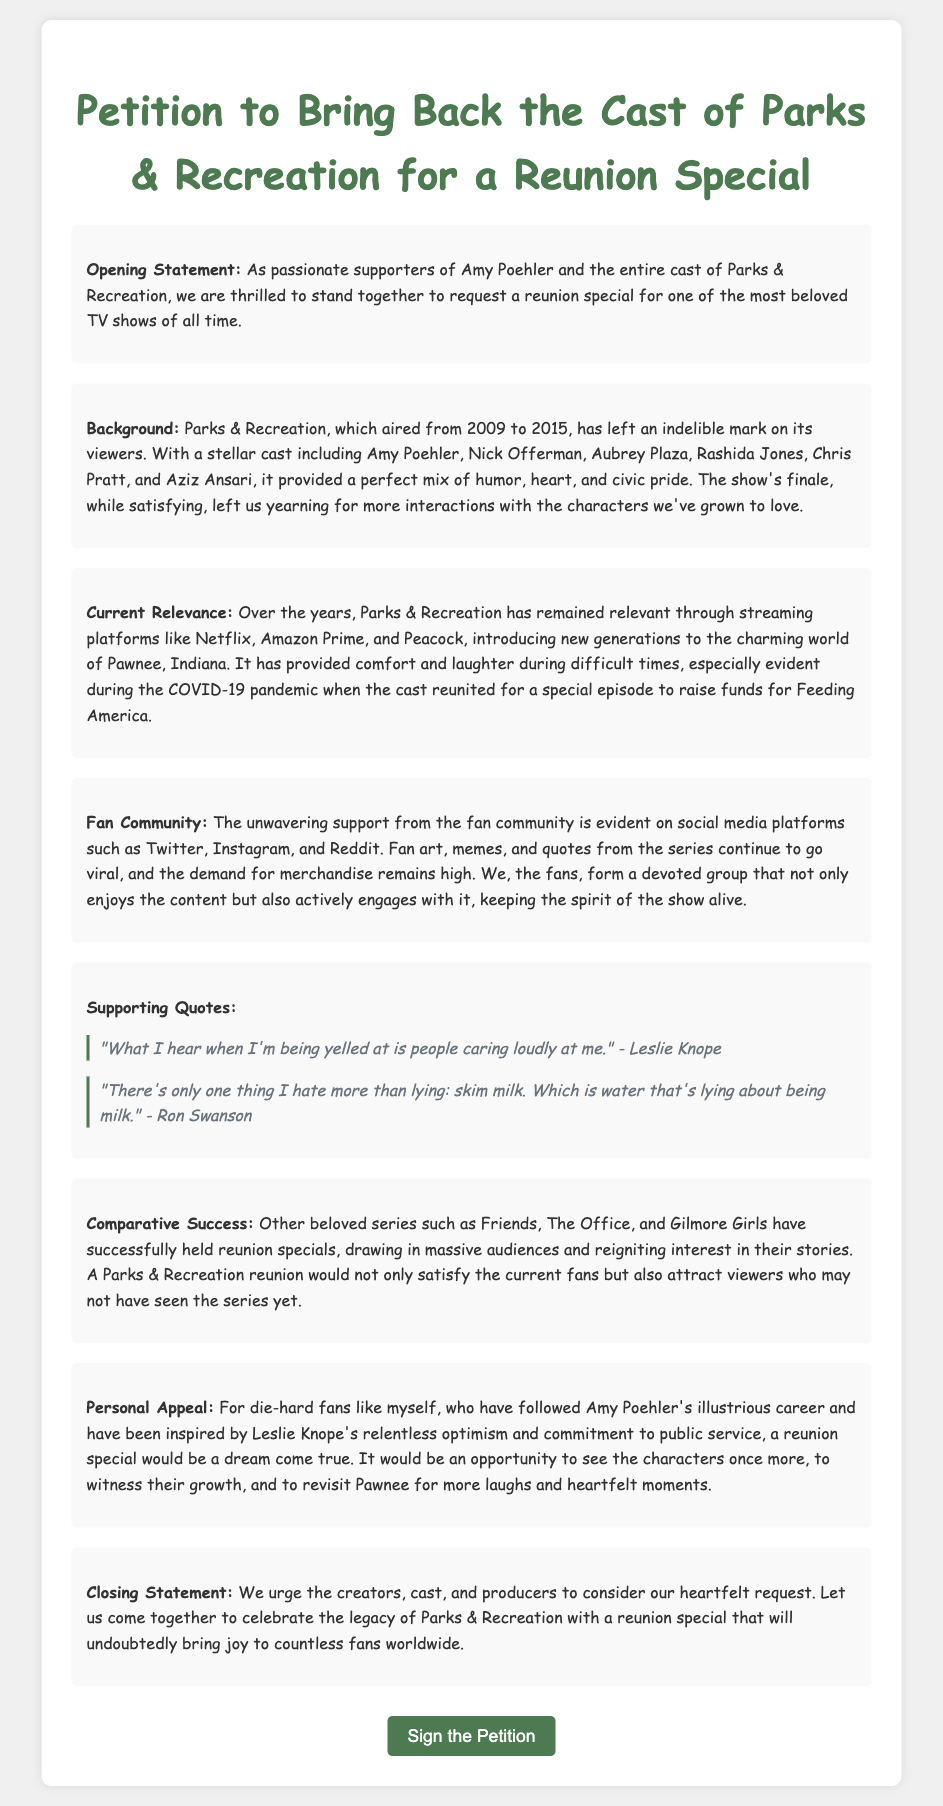What is the title of the petition? The title of the petition is explicitly stated at the top of the document.
Answer: Petition to Bring Back the Cast of Parks & Recreation for a Reunion Special Who is the creator of the character Leslie Knope? Leslie Knope is played by Amy Poehler, a main cast member and a driving force behind the show.
Answer: Amy Poehler What year did Parks & Recreation first air? The document mentions the airing period of the show clearly.
Answer: 2009 What was the purpose of the special episode during the COVID-19 pandemic? The document refers to an event that aimed to aid a charitable cause.
Answer: To raise funds for Feeding America Which platforms have kept Parks & Recreation relevant? The document lists the streaming platforms that have introduced the show to new audiences.
Answer: Netflix, Amazon Prime, and Peacock How many quotes are included in the supporting quotes section? By counting the quotes presented in the corresponding section, we can determine the number of quotes.
Answer: 2 What other series are mentioned as having successful reunion specials? The document compares with other successful shows that have had reunion specials.
Answer: Friends, The Office, and Gilmore Girls What is the primary appeal made in the closing statement? The situation summarized in the closing statement reflects the urgency and emotional aspect of the request.
Answer: Celebrate the legacy of Parks & Recreation with a reunion special 